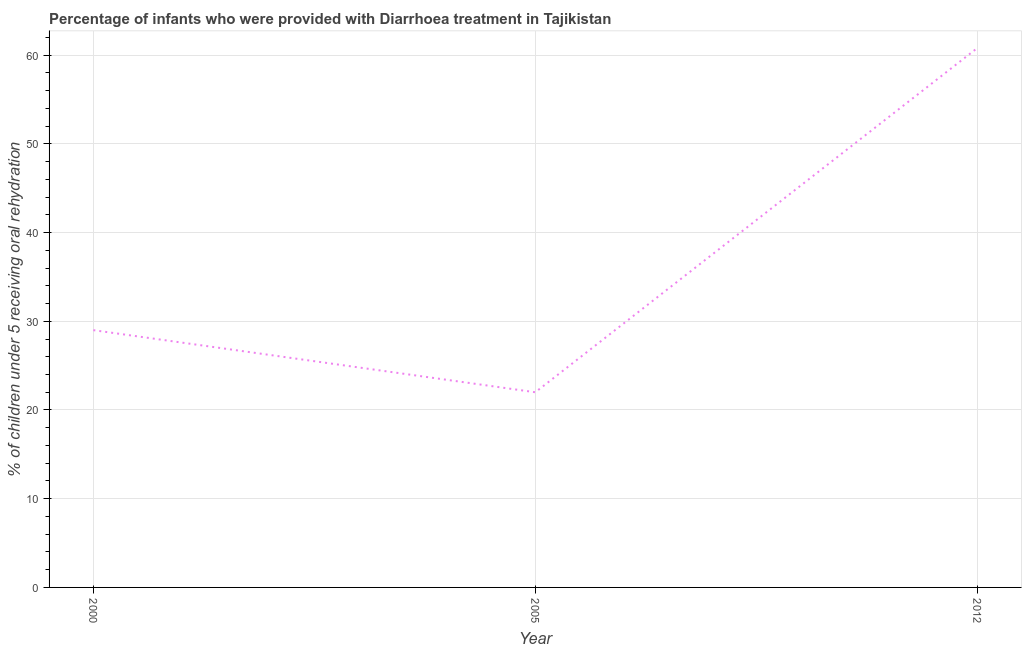What is the percentage of children who were provided with treatment diarrhoea in 2005?
Make the answer very short. 22. Across all years, what is the maximum percentage of children who were provided with treatment diarrhoea?
Your answer should be very brief. 60.8. In which year was the percentage of children who were provided with treatment diarrhoea minimum?
Your answer should be compact. 2005. What is the sum of the percentage of children who were provided with treatment diarrhoea?
Provide a short and direct response. 111.8. What is the difference between the percentage of children who were provided with treatment diarrhoea in 2000 and 2005?
Give a very brief answer. 7. What is the average percentage of children who were provided with treatment diarrhoea per year?
Your answer should be compact. 37.27. What is the median percentage of children who were provided with treatment diarrhoea?
Keep it short and to the point. 29. What is the ratio of the percentage of children who were provided with treatment diarrhoea in 2000 to that in 2012?
Make the answer very short. 0.48. What is the difference between the highest and the second highest percentage of children who were provided with treatment diarrhoea?
Provide a succinct answer. 31.8. Is the sum of the percentage of children who were provided with treatment diarrhoea in 2000 and 2012 greater than the maximum percentage of children who were provided with treatment diarrhoea across all years?
Your answer should be very brief. Yes. What is the difference between the highest and the lowest percentage of children who were provided with treatment diarrhoea?
Offer a terse response. 38.8. Does the percentage of children who were provided with treatment diarrhoea monotonically increase over the years?
Your answer should be compact. No. How many lines are there?
Your answer should be compact. 1. How many years are there in the graph?
Give a very brief answer. 3. What is the title of the graph?
Offer a terse response. Percentage of infants who were provided with Diarrhoea treatment in Tajikistan. What is the label or title of the X-axis?
Offer a very short reply. Year. What is the label or title of the Y-axis?
Provide a succinct answer. % of children under 5 receiving oral rehydration. What is the % of children under 5 receiving oral rehydration in 2000?
Make the answer very short. 29. What is the % of children under 5 receiving oral rehydration of 2005?
Your response must be concise. 22. What is the % of children under 5 receiving oral rehydration of 2012?
Provide a short and direct response. 60.8. What is the difference between the % of children under 5 receiving oral rehydration in 2000 and 2005?
Provide a succinct answer. 7. What is the difference between the % of children under 5 receiving oral rehydration in 2000 and 2012?
Provide a succinct answer. -31.8. What is the difference between the % of children under 5 receiving oral rehydration in 2005 and 2012?
Provide a succinct answer. -38.8. What is the ratio of the % of children under 5 receiving oral rehydration in 2000 to that in 2005?
Keep it short and to the point. 1.32. What is the ratio of the % of children under 5 receiving oral rehydration in 2000 to that in 2012?
Your answer should be very brief. 0.48. What is the ratio of the % of children under 5 receiving oral rehydration in 2005 to that in 2012?
Provide a short and direct response. 0.36. 